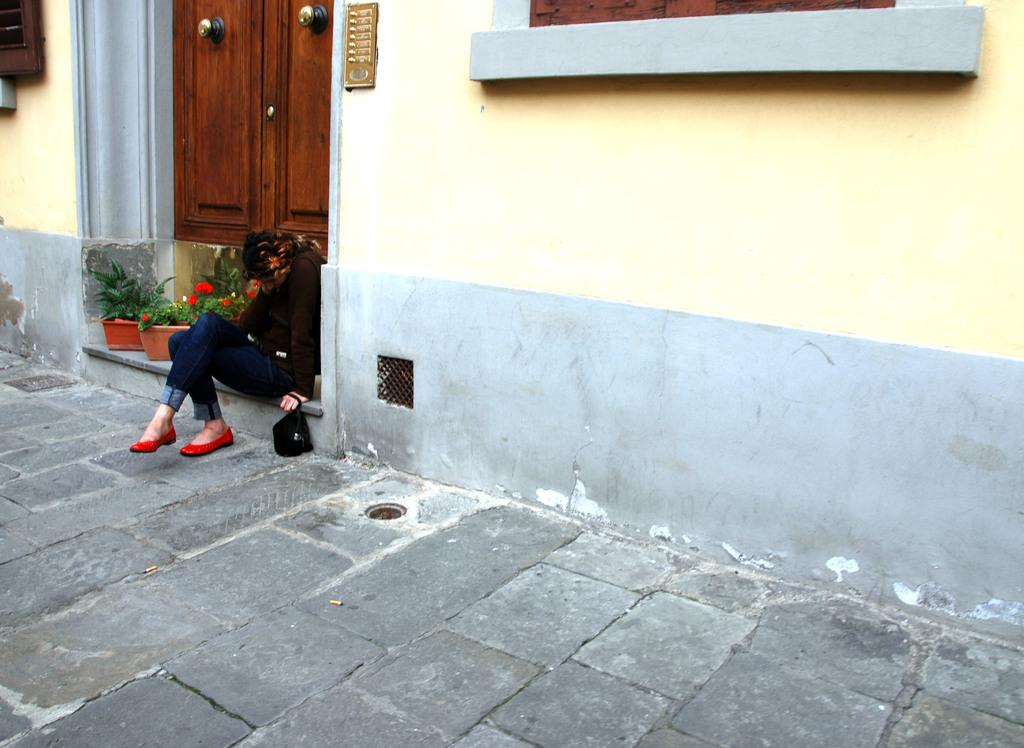What is the woman in the image doing? The woman is sitting on the floor in the image. What is the woman holding in her hand? The woman is holding a bag in her hand. What can be seen in the image besides the woman? There are pots in the image, and the pots have plants in them. What is visible in the background of the image? There is a wall in the background of the image, and the wall has a window. Can you see a tiger walking through the window in the image? No, there is no tiger or any animal visible in the image. The image only shows a woman sitting on the floor, holding a bag, and pots with plants, along with a wall and a window in the background. 